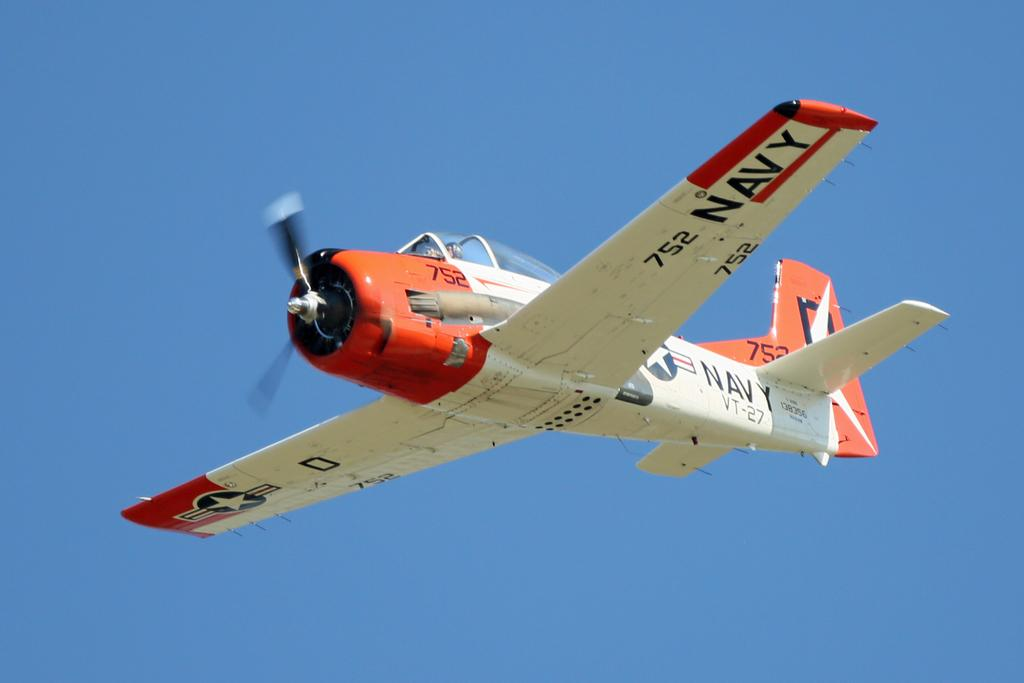<image>
Offer a succinct explanation of the picture presented. A propeller driven airplane that is part of the U.S. Navy. 